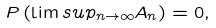Convert formula to latex. <formula><loc_0><loc_0><loc_500><loc_500>P \left ( \lim s u p _ { n \to \infty } A _ { n } \right ) = 0 ,</formula> 